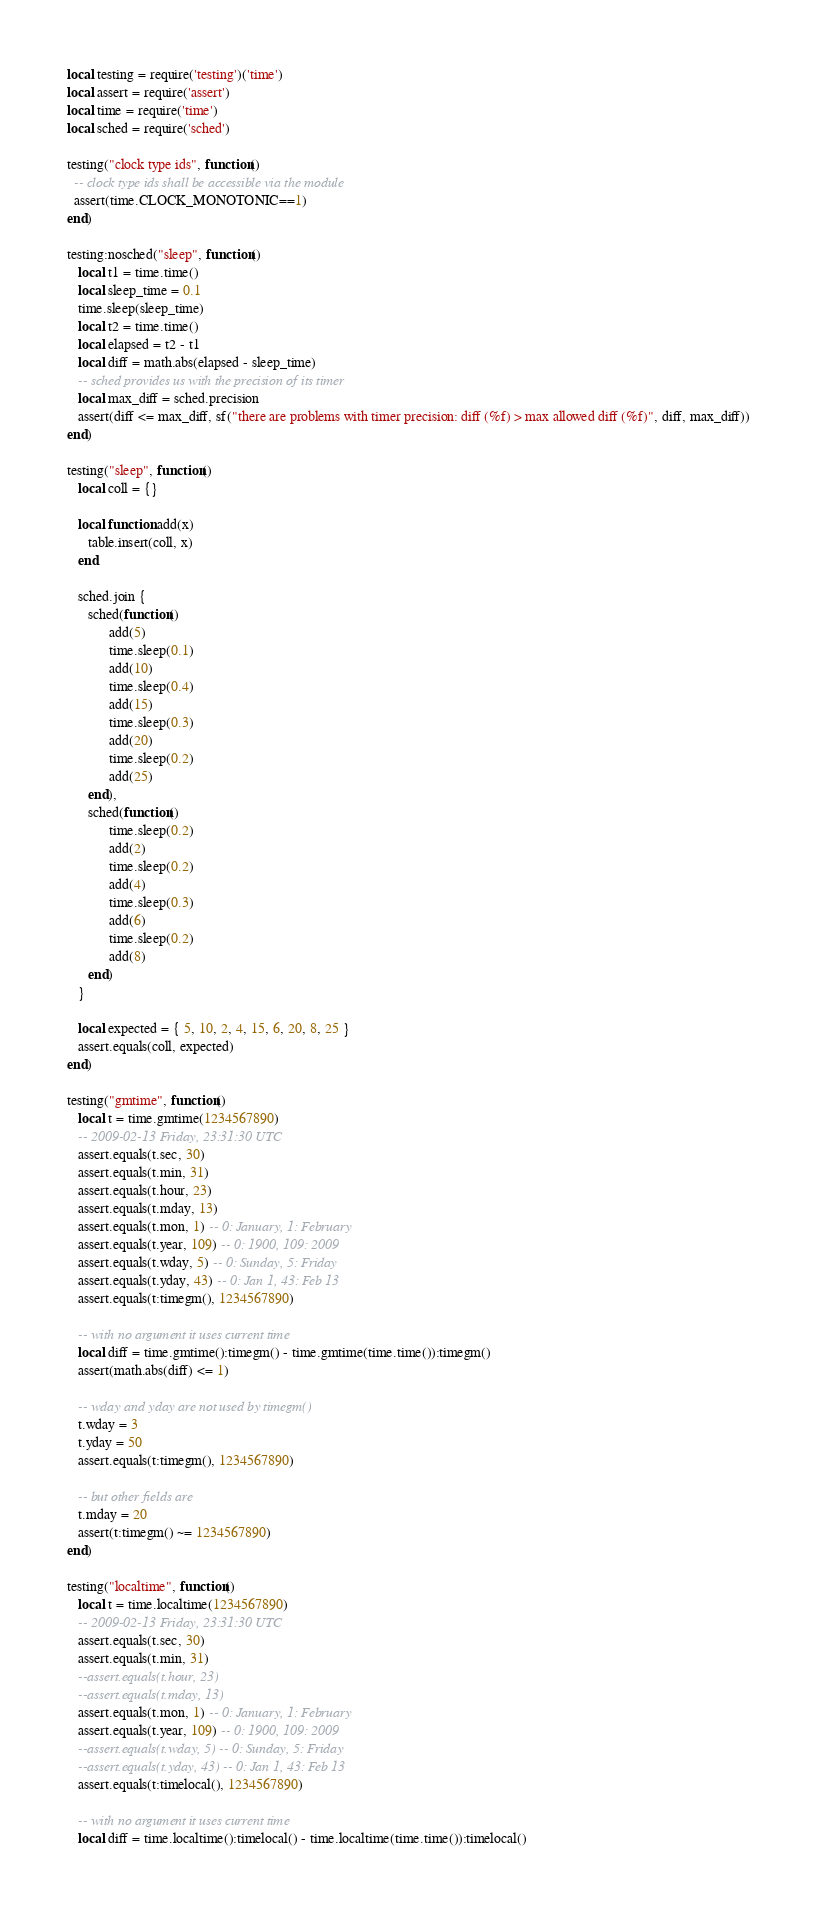Convert code to text. <code><loc_0><loc_0><loc_500><loc_500><_Lua_>local testing = require('testing')('time')
local assert = require('assert')
local time = require('time')
local sched = require('sched')

testing("clock type ids", function()
  -- clock type ids shall be accessible via the module
  assert(time.CLOCK_MONOTONIC==1)
end)

testing:nosched("sleep", function()
   local t1 = time.time()
   local sleep_time = 0.1
   time.sleep(sleep_time)
   local t2 = time.time()
   local elapsed = t2 - t1
   local diff = math.abs(elapsed - sleep_time)
   -- sched provides us with the precision of its timer
   local max_diff = sched.precision
   assert(diff <= max_diff, sf("there are problems with timer precision: diff (%f) > max allowed diff (%f)", diff, max_diff))
end)

testing("sleep", function()
   local coll = {}

   local function add(x)
      table.insert(coll, x)
   end

   sched.join {
      sched(function()
            add(5)
            time.sleep(0.1)
            add(10)
            time.sleep(0.4)
            add(15)
            time.sleep(0.3)
            add(20)
            time.sleep(0.2)
            add(25)
      end),
      sched(function()
            time.sleep(0.2)
            add(2)
            time.sleep(0.2)
            add(4)
            time.sleep(0.3)
            add(6)
            time.sleep(0.2)
            add(8)
      end)
   }

   local expected = { 5, 10, 2, 4, 15, 6, 20, 8, 25 }
   assert.equals(coll, expected)
end)

testing("gmtime", function()
   local t = time.gmtime(1234567890)
   -- 2009-02-13 Friday, 23:31:30 UTC
   assert.equals(t.sec, 30)
   assert.equals(t.min, 31)
   assert.equals(t.hour, 23)
   assert.equals(t.mday, 13)
   assert.equals(t.mon, 1) -- 0: January, 1: February
   assert.equals(t.year, 109) -- 0: 1900, 109: 2009
   assert.equals(t.wday, 5) -- 0: Sunday, 5: Friday
   assert.equals(t.yday, 43) -- 0: Jan 1, 43: Feb 13
   assert.equals(t:timegm(), 1234567890)

   -- with no argument it uses current time
   local diff = time.gmtime():timegm() - time.gmtime(time.time()):timegm()
   assert(math.abs(diff) <= 1)

   -- wday and yday are not used by timegm()
   t.wday = 3
   t.yday = 50
   assert.equals(t:timegm(), 1234567890)

   -- but other fields are
   t.mday = 20
   assert(t:timegm() ~= 1234567890)
end)

testing("localtime", function()
   local t = time.localtime(1234567890)
   -- 2009-02-13 Friday, 23:31:30 UTC
   assert.equals(t.sec, 30)
   assert.equals(t.min, 31)
   --assert.equals(t.hour, 23)
   --assert.equals(t.mday, 13)
   assert.equals(t.mon, 1) -- 0: January, 1: February
   assert.equals(t.year, 109) -- 0: 1900, 109: 2009
   --assert.equals(t.wday, 5) -- 0: Sunday, 5: Friday
   --assert.equals(t.yday, 43) -- 0: Jan 1, 43: Feb 13
   assert.equals(t:timelocal(), 1234567890)

   -- with no argument it uses current time
   local diff = time.localtime():timelocal() - time.localtime(time.time()):timelocal()</code> 